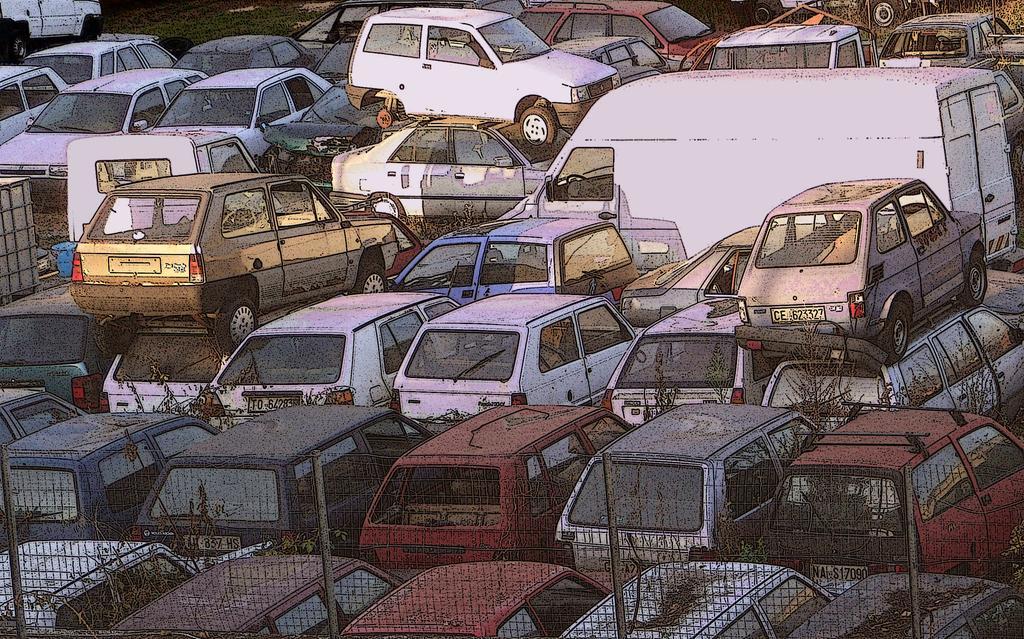Please provide a concise description of this image. In this image we can see vehicles, plants and mesh. 